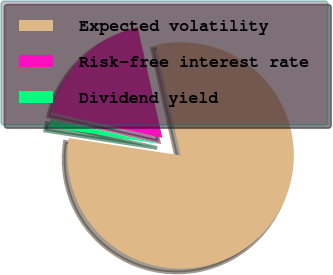Convert chart. <chart><loc_0><loc_0><loc_500><loc_500><pie_chart><fcel>Expected volatility<fcel>Risk-free interest rate<fcel>Dividend yield<nl><fcel>80.94%<fcel>17.95%<fcel>1.1%<nl></chart> 